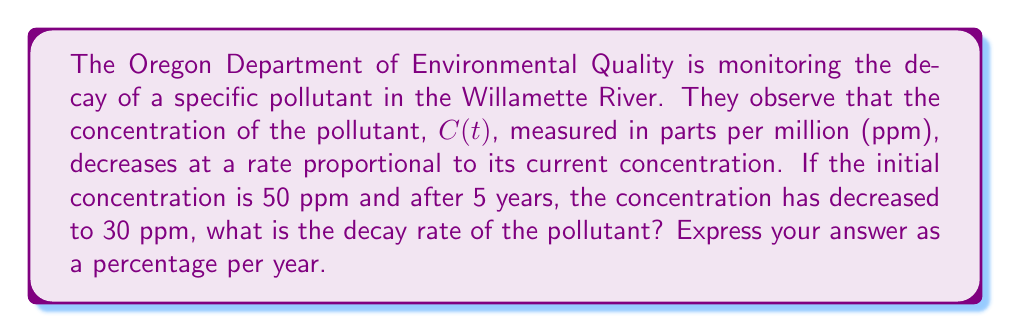Can you answer this question? Let's approach this step-by-step using a first-order differential equation:

1) The rate of change of the concentration is proportional to the current concentration. This can be expressed as:

   $$\frac{dC}{dt} = -kC$$

   where $k$ is the decay constant (rate) we need to find.

2) The solution to this differential equation is:

   $$C(t) = C_0e^{-kt}$$

   where $C_0$ is the initial concentration.

3) We're given that:
   - $C_0 = 50$ ppm (initial concentration)
   - $C(5) = 30$ ppm (concentration after 5 years)

4) Let's substitute these values into our equation:

   $$30 = 50e^{-5k}$$

5) Divide both sides by 50:

   $$\frac{3}{5} = e^{-5k}$$

6) Take the natural log of both sides:

   $$\ln(\frac{3}{5}) = -5k$$

7) Solve for $k$:

   $$k = -\frac{1}{5}\ln(\frac{3}{5}) \approx 0.1054$$

8) This $k$ value represents the decay rate per year. To express it as a percentage, multiply by 100:

   Decay rate = $0.1054 * 100 \approx 10.54\%$ per year

This means the pollutant concentration is decreasing by about 10.54% each year.
Answer: The decay rate of the pollutant is approximately 10.54% per year. 